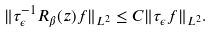<formula> <loc_0><loc_0><loc_500><loc_500>\| \tau _ { \epsilon } ^ { - 1 } R _ { \beta } ( z ) f \| _ { L ^ { 2 } } \leq C \| \tau _ { \epsilon } f \| _ { L ^ { 2 } } .</formula> 